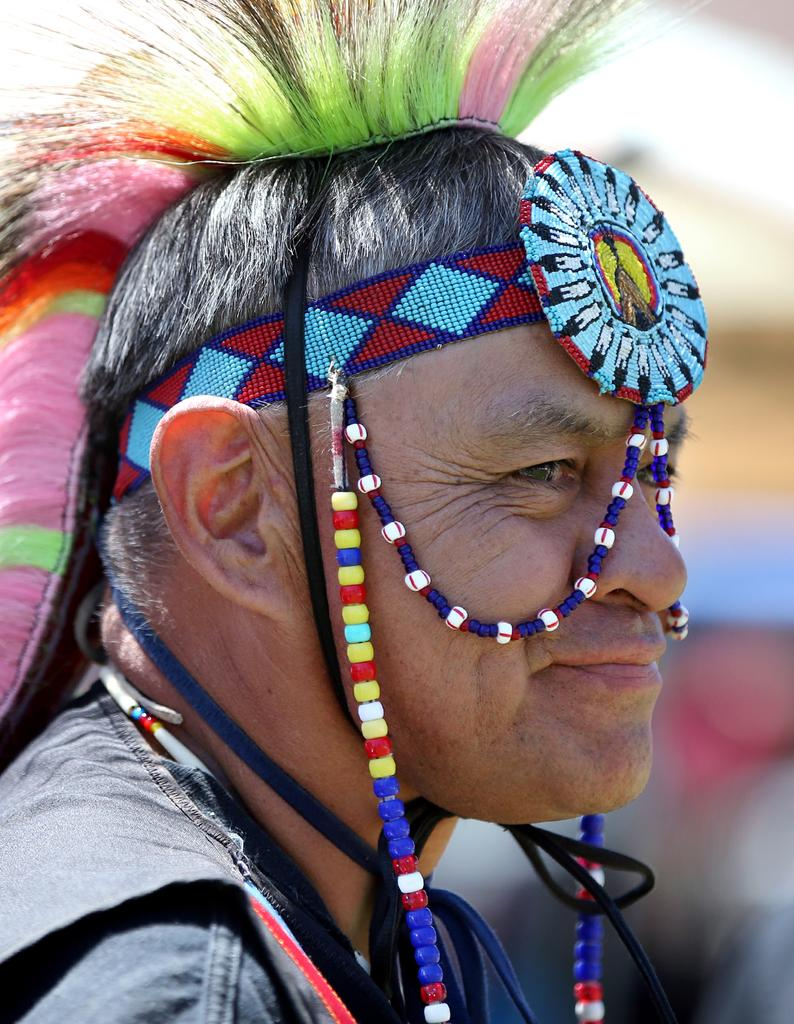Who is present in the image? There is a man in the image. What is the man wearing? The man is wearing a costume. Can you describe the background of the image? The background of the image is blurred. What type of fish can be seen swimming in the background of the image? There is no fish present in the image; the background is blurred. 